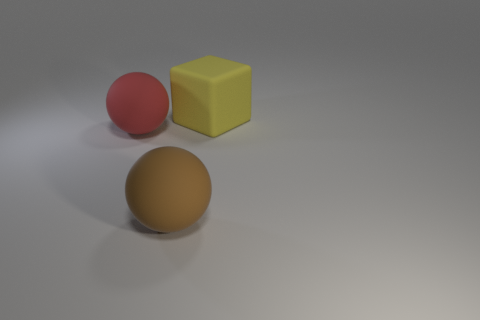There is another large object that is the same shape as the red matte object; what is its color?
Offer a very short reply. Brown. There is a big object that is behind the matte ball left of the brown object; are there any yellow cubes to the right of it?
Make the answer very short. No. Is the shape of the large red matte thing the same as the big yellow rubber object?
Ensure brevity in your answer.  No. Is the number of large red matte things in front of the big brown sphere less than the number of big red balls?
Give a very brief answer. Yes. There is a big ball that is on the right side of the thing to the left of the large matte thing that is in front of the red ball; what color is it?
Your answer should be very brief. Brown. How many rubber things are large red spheres or big brown objects?
Make the answer very short. 2. Do the yellow block and the red matte thing have the same size?
Your response must be concise. Yes. Are there fewer large red things in front of the brown matte ball than red matte spheres that are behind the big yellow rubber block?
Ensure brevity in your answer.  No. Are there any other things that have the same size as the red matte object?
Your response must be concise. Yes. The cube has what size?
Provide a short and direct response. Large. 